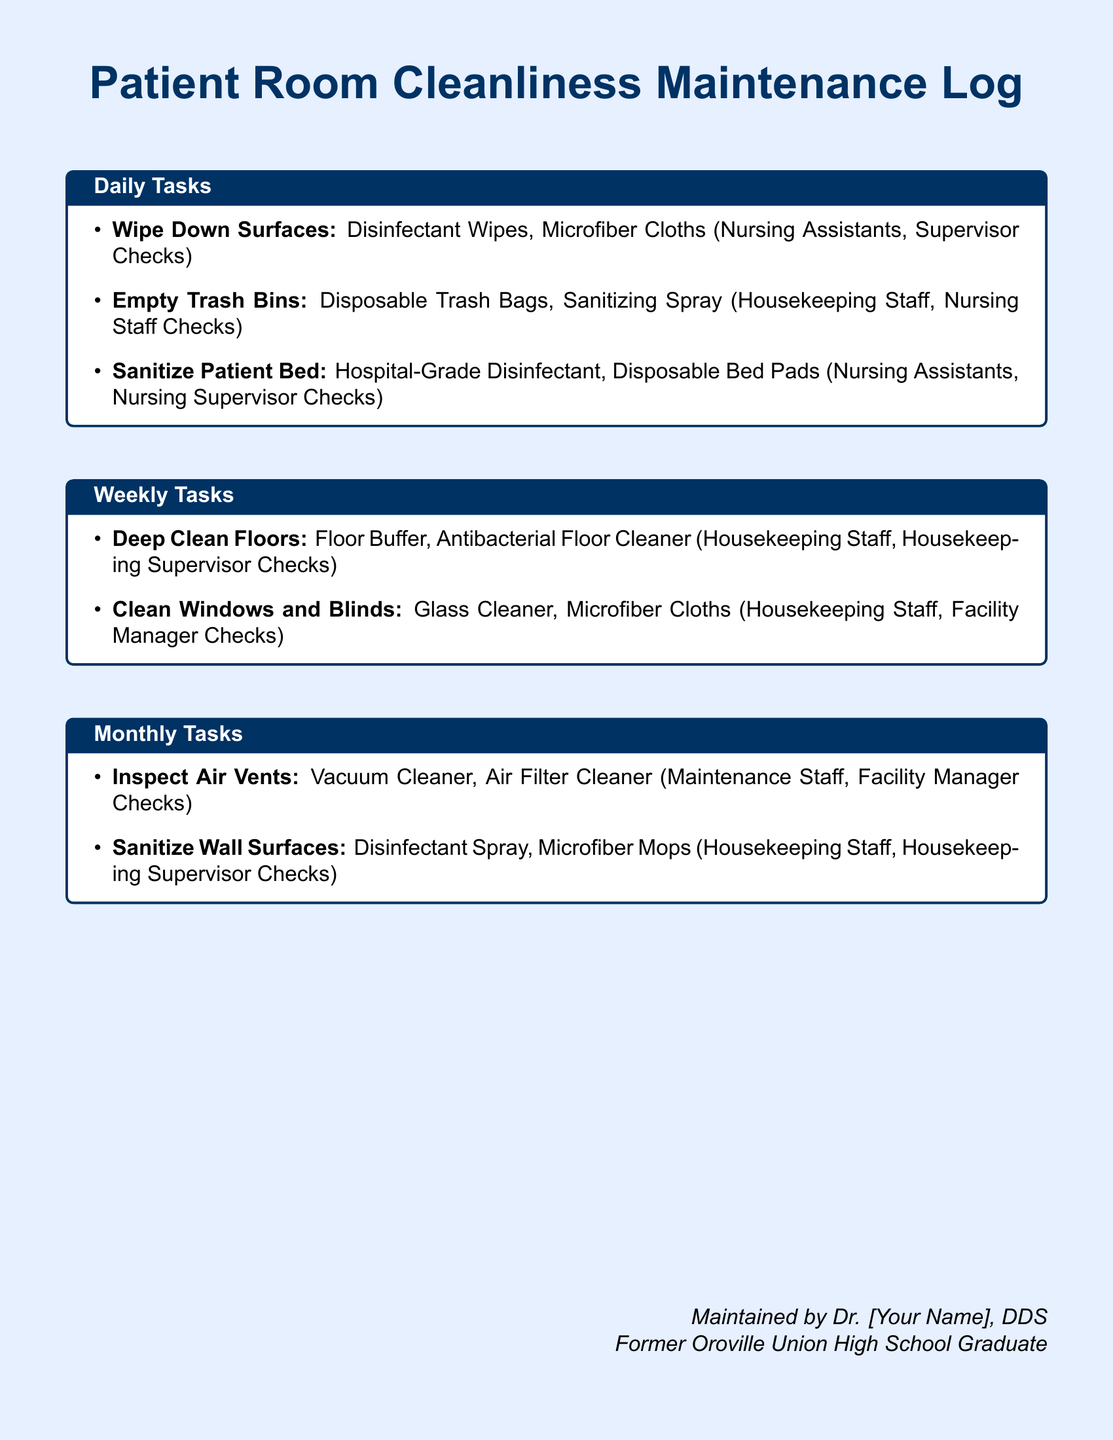what are the daily cleaning tasks? The daily cleaning tasks include wiping down surfaces, emptying trash bins, and sanitizing patient beds.
Answer: wiping down surfaces, emptying trash bins, sanitizing patient beds who checks the cleaning of patient beds? The nursing supervisor checks the cleaning of patient beds.
Answer: Nursing Supervisor Checks what type of cleaner is used for deep cleaning floors? The type of cleaner used for deep cleaning floors is antibacterial floor cleaner.
Answer: Antibacterial Floor Cleaner how often are air vents inspected? Air vents are inspected monthly.
Answer: monthly who maintains the cleanliness log? The log is maintained by Dr. [Your Name], DDS.
Answer: Dr. [Your Name], DDS which staff is responsible for cleaning windows and blinds? The housekeeping staff is responsible for cleaning windows and blinds.
Answer: Housekeeping Staff what is the cleaning material used for sanitizing wall surfaces? The cleaning material used for sanitizing wall surfaces is disinfectant spray.
Answer: Disinfectant Spray how frequently are floors deep cleaned? Floors are deep cleaned weekly.
Answer: weekly what is the main color used in the document? The main color used in the document is light blue.
Answer: light blue 